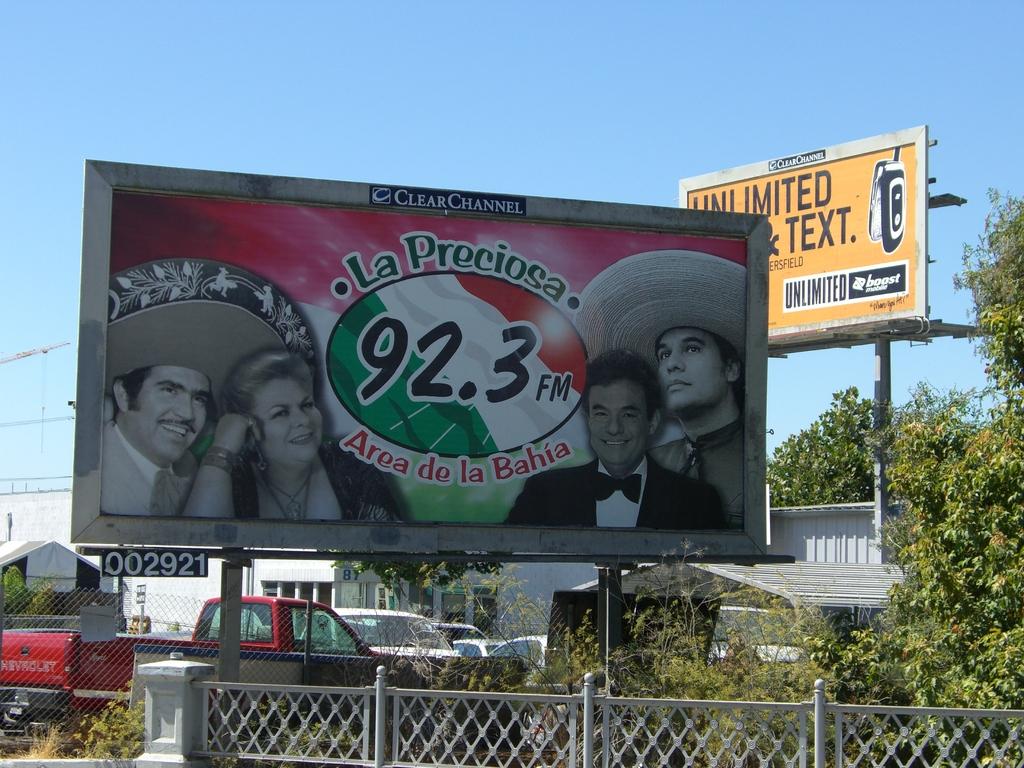What station is be advertised?
Offer a terse response. 92.3 fm. What is the number of the station is listed?
Give a very brief answer. 92.3. 